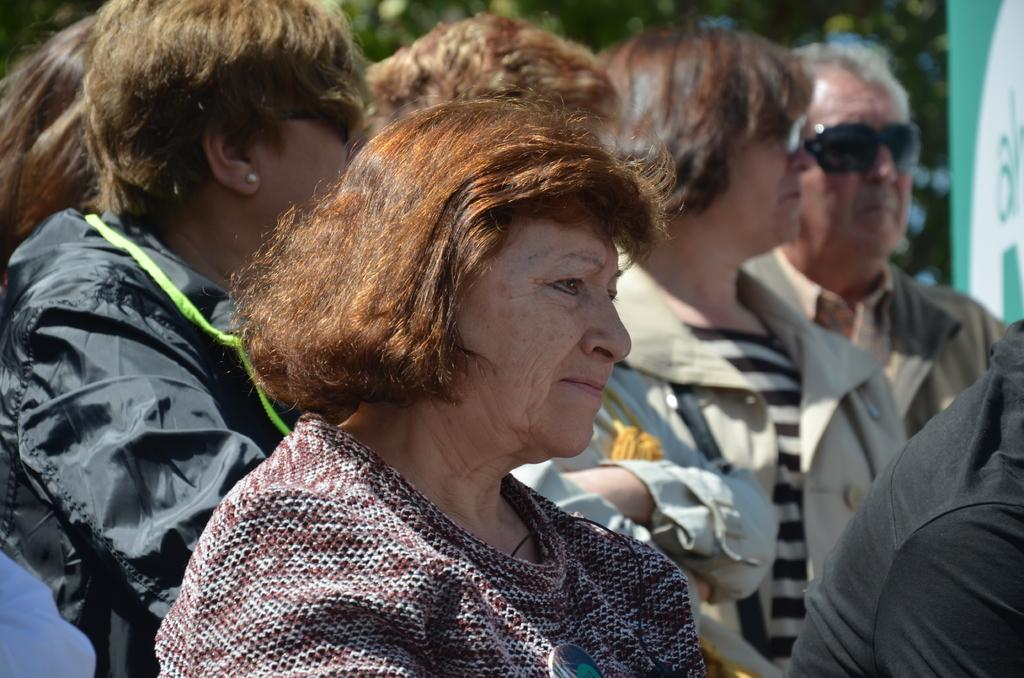How many people are in the group visible in the image? The number of people in the group cannot be determined from the provided facts. What is the board visible in the image used for? The purpose of the board visible in the image cannot be determined from the provided facts. What type of vegetation is present in the image? There are trees in the image. What type of milk is being poured from the comb in the image? There is no milk or comb present in the image. 